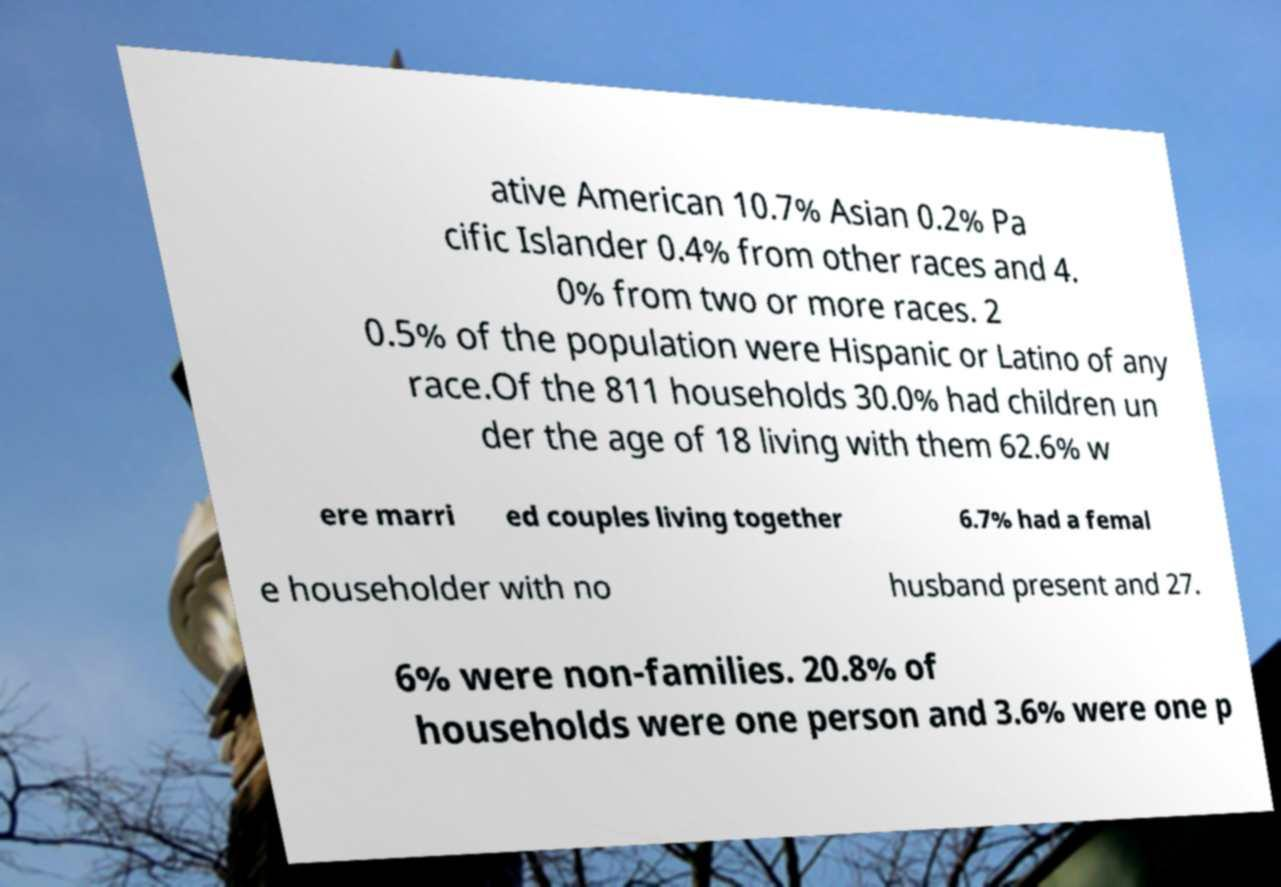Can you accurately transcribe the text from the provided image for me? ative American 10.7% Asian 0.2% Pa cific Islander 0.4% from other races and 4. 0% from two or more races. 2 0.5% of the population were Hispanic or Latino of any race.Of the 811 households 30.0% had children un der the age of 18 living with them 62.6% w ere marri ed couples living together 6.7% had a femal e householder with no husband present and 27. 6% were non-families. 20.8% of households were one person and 3.6% were one p 